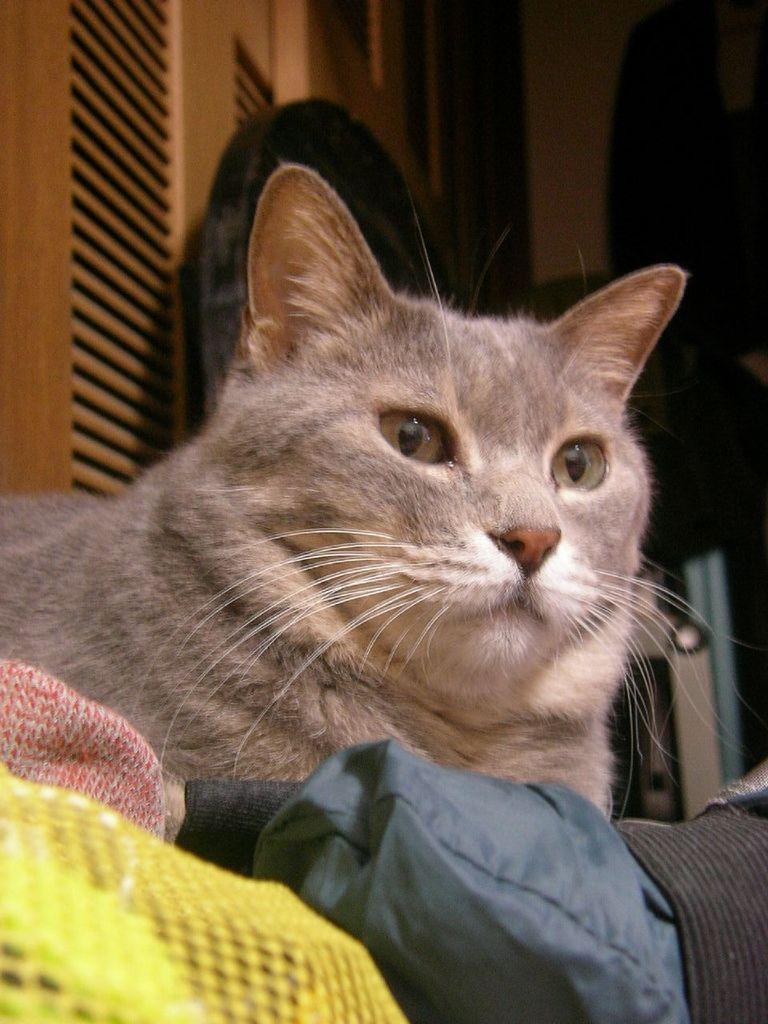Please provide a concise description of this image. In this picture we can see a cat, clothes and in the background we can see some objects. 